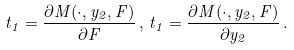<formula> <loc_0><loc_0><loc_500><loc_500>t _ { 1 } = \frac { \partial M ( \cdot , y _ { 2 } , F ) } { \partial F } \, , \, t _ { 1 } = \frac { \partial M ( \cdot , y _ { 2 } , F ) } { \partial y _ { 2 } } \, .</formula> 